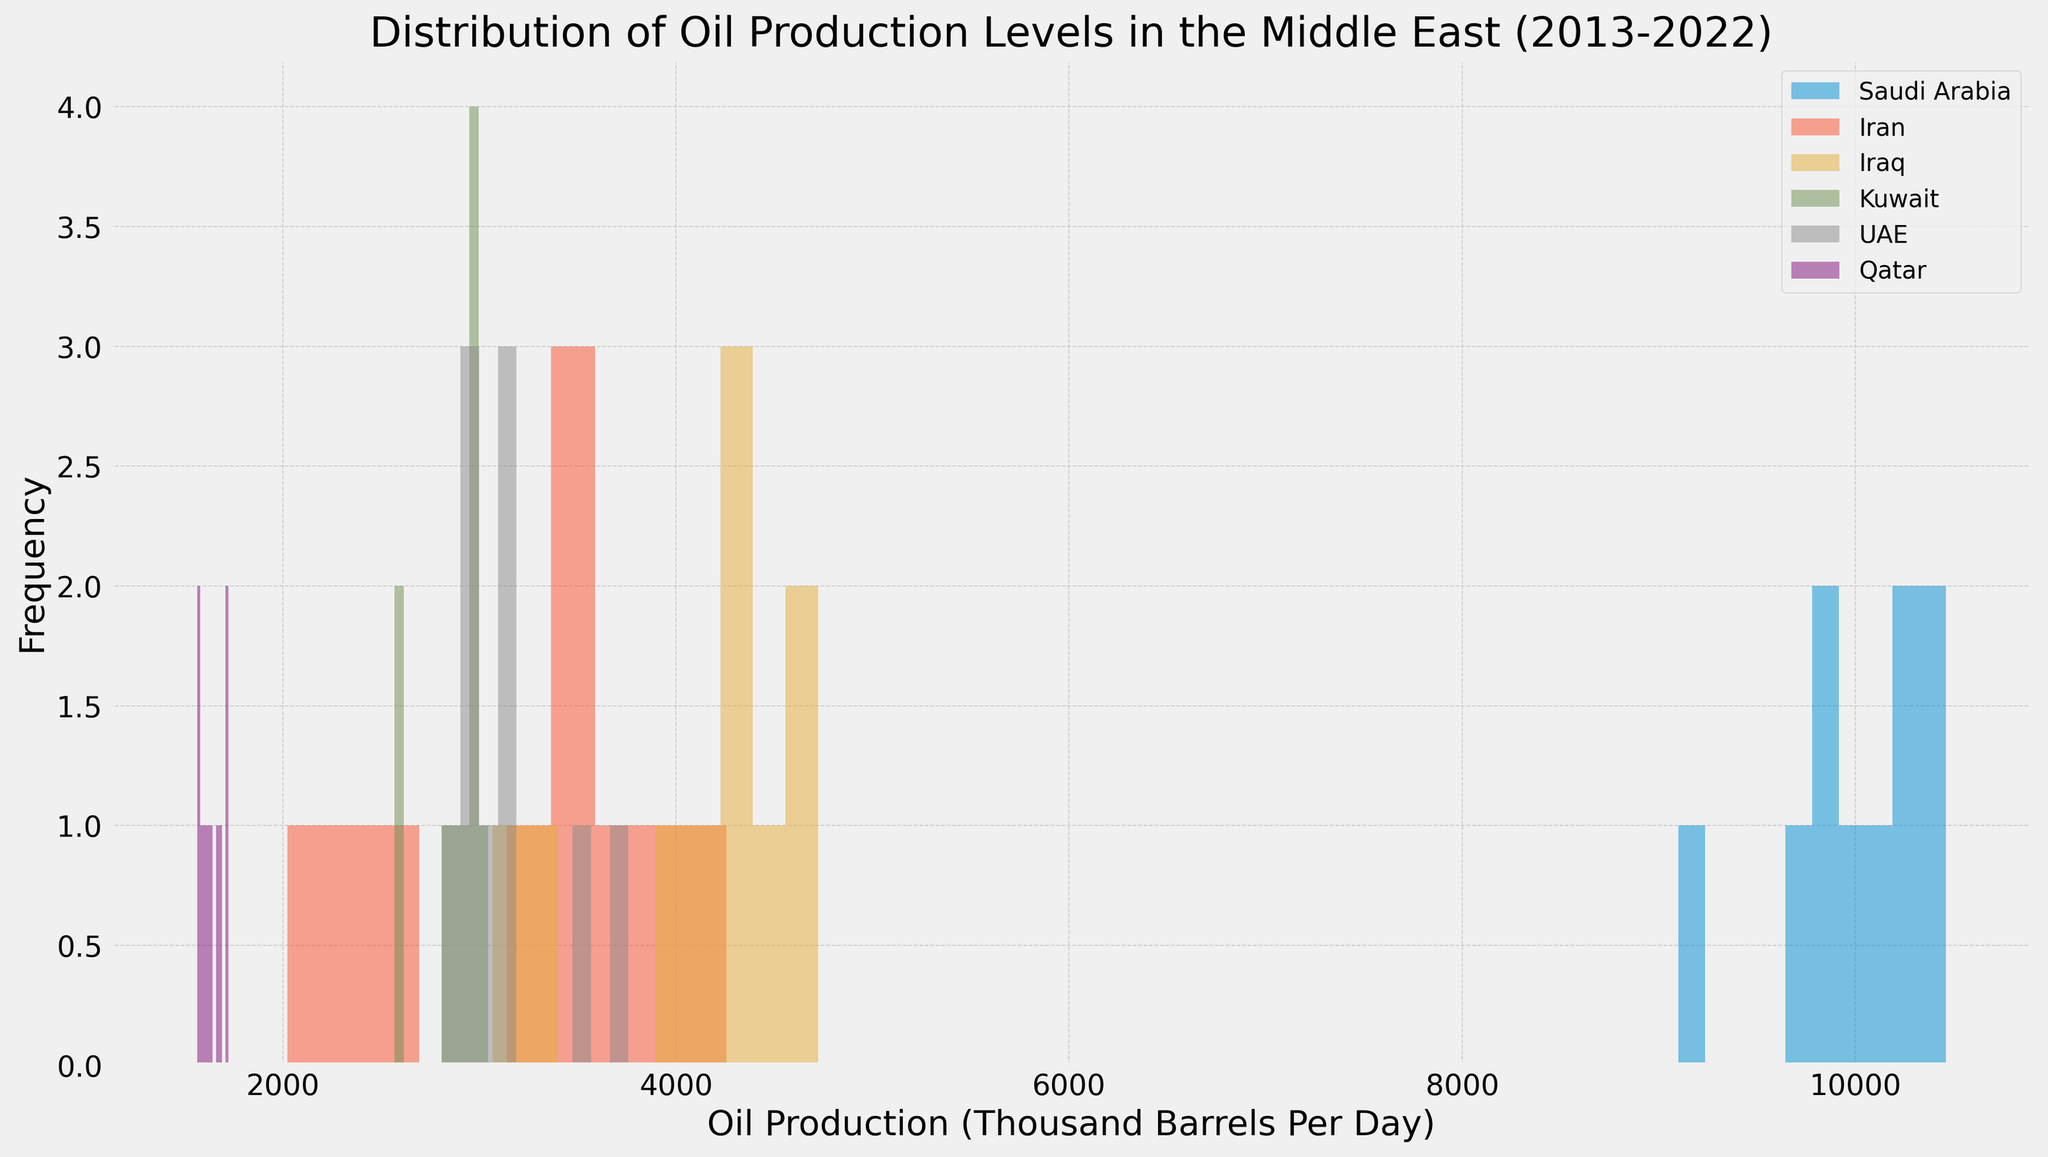What is the frequency of the highest oil production level for Saudi Arabia? To find the frequency of the highest oil production level for Saudi Arabia, look for the tallest histogram bar in the plot that represents Saudi Arabia. The height of that bar is the frequency.
Answer: Frequency of highest oil production is 2 Between Iran and Iraq, which country has higher oil production levels more frequently? Compare the heights of histogram bars for both Iran and Iraq. Larger bars indicate higher frequency of oil production levels. Iraq's bars are generally higher than Iran's.
Answer: Iraq What is the range of oil production levels for Kuwait as shown in the histogram? To find the range, look at the lowest and highest bins for Kuwait's histogram and note their corresponding production levels. The range is the difference between the highest and lowest production levels.
Answer: The range is approximately between 2500 and 3100 Which country appears to have the most consistent (less variable) oil production levels? Consistent production levels would be indicated by a histogram with fewer, taller bars closely grouped together.
Answer: Saudi Arabia Does Qatar have any year with oil production over 2000 thousand barrels per day as shown in the histogram? Check for any bars for Qatar that indicate oil production levels surpassing 2000 thousand barrels per day.
Answer: No What's the median oil production level for UAE? Identify the middle value of the oil production histogram bins for UAE. The value at the middle bar height-wise represents the median.
Answer: Approximately 3100 thousand barrels per day How does the oil production distribution of Iran compare with that of Kuwait in terms of skewness? Check the shape of the histograms for both Iran and Kuwait. If the bars are skewed towards lower or higher production levels, this indicates skewness.
Answer: Iran's is right-skewed; Kuwait's is less skewed What is the most frequent oil production level for Iraq? Find the tallest bar in Iraq's histogram and read off the corresponding oil production level.
Answer: Approximately 4300-4500 thousand barrels per day Between UAE and Qatar, which country shows more variability in oil production levels? Compare the spread and number of distinct bars in the histograms for UAE and Qatar. More spread indicates more variability.
Answer: UAE What is the overall highest oil production level observed in the histogram? Identify which country has the rightmost histogram bar and read the value. This represents the highest production level.
Answer: Approximately 10700 thousand barrels per day (Saudi Arabia) 